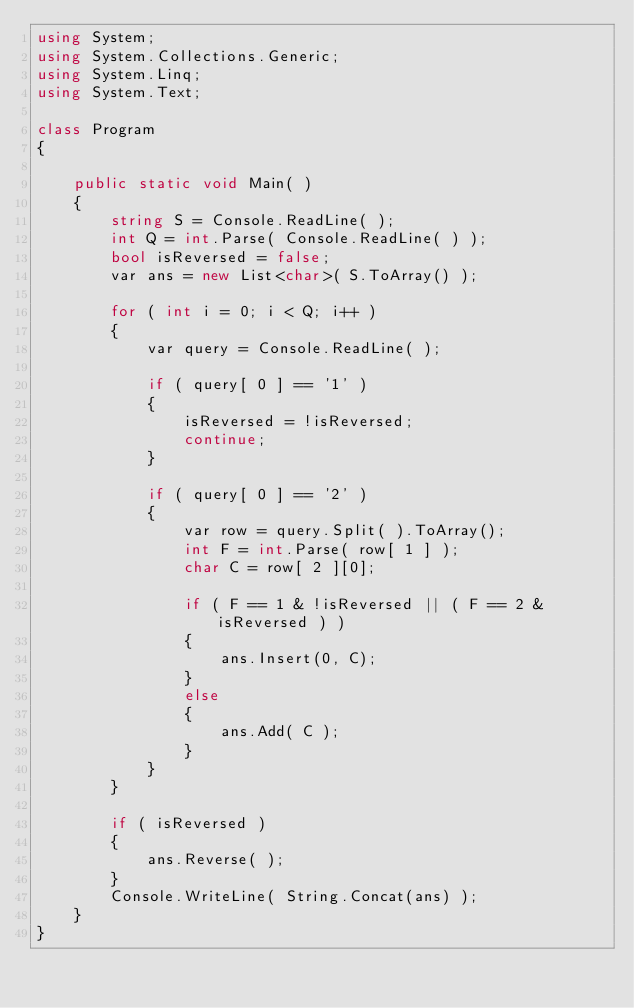<code> <loc_0><loc_0><loc_500><loc_500><_C#_>using System;
using System.Collections.Generic;
using System.Linq;
using System.Text;

class Program
{

    public static void Main( )
    {
        string S = Console.ReadLine( );
        int Q = int.Parse( Console.ReadLine( ) );
        bool isReversed = false;
        var ans = new List<char>( S.ToArray() );

        for ( int i = 0; i < Q; i++ )
        {
            var query = Console.ReadLine( );

            if ( query[ 0 ] == '1' )
            {
                isReversed = !isReversed;
                continue;
            }

            if ( query[ 0 ] == '2' )
            {
                var row = query.Split( ).ToArray();
                int F = int.Parse( row[ 1 ] );
                char C = row[ 2 ][0];

                if ( F == 1 & !isReversed || ( F == 2 & isReversed ) )
                {
                    ans.Insert(0, C);
                }
                else
                {
                    ans.Add( C );
                }
            }
        }

        if ( isReversed )
        {
            ans.Reverse( );
        }
        Console.WriteLine( String.Concat(ans) );
    }
}</code> 